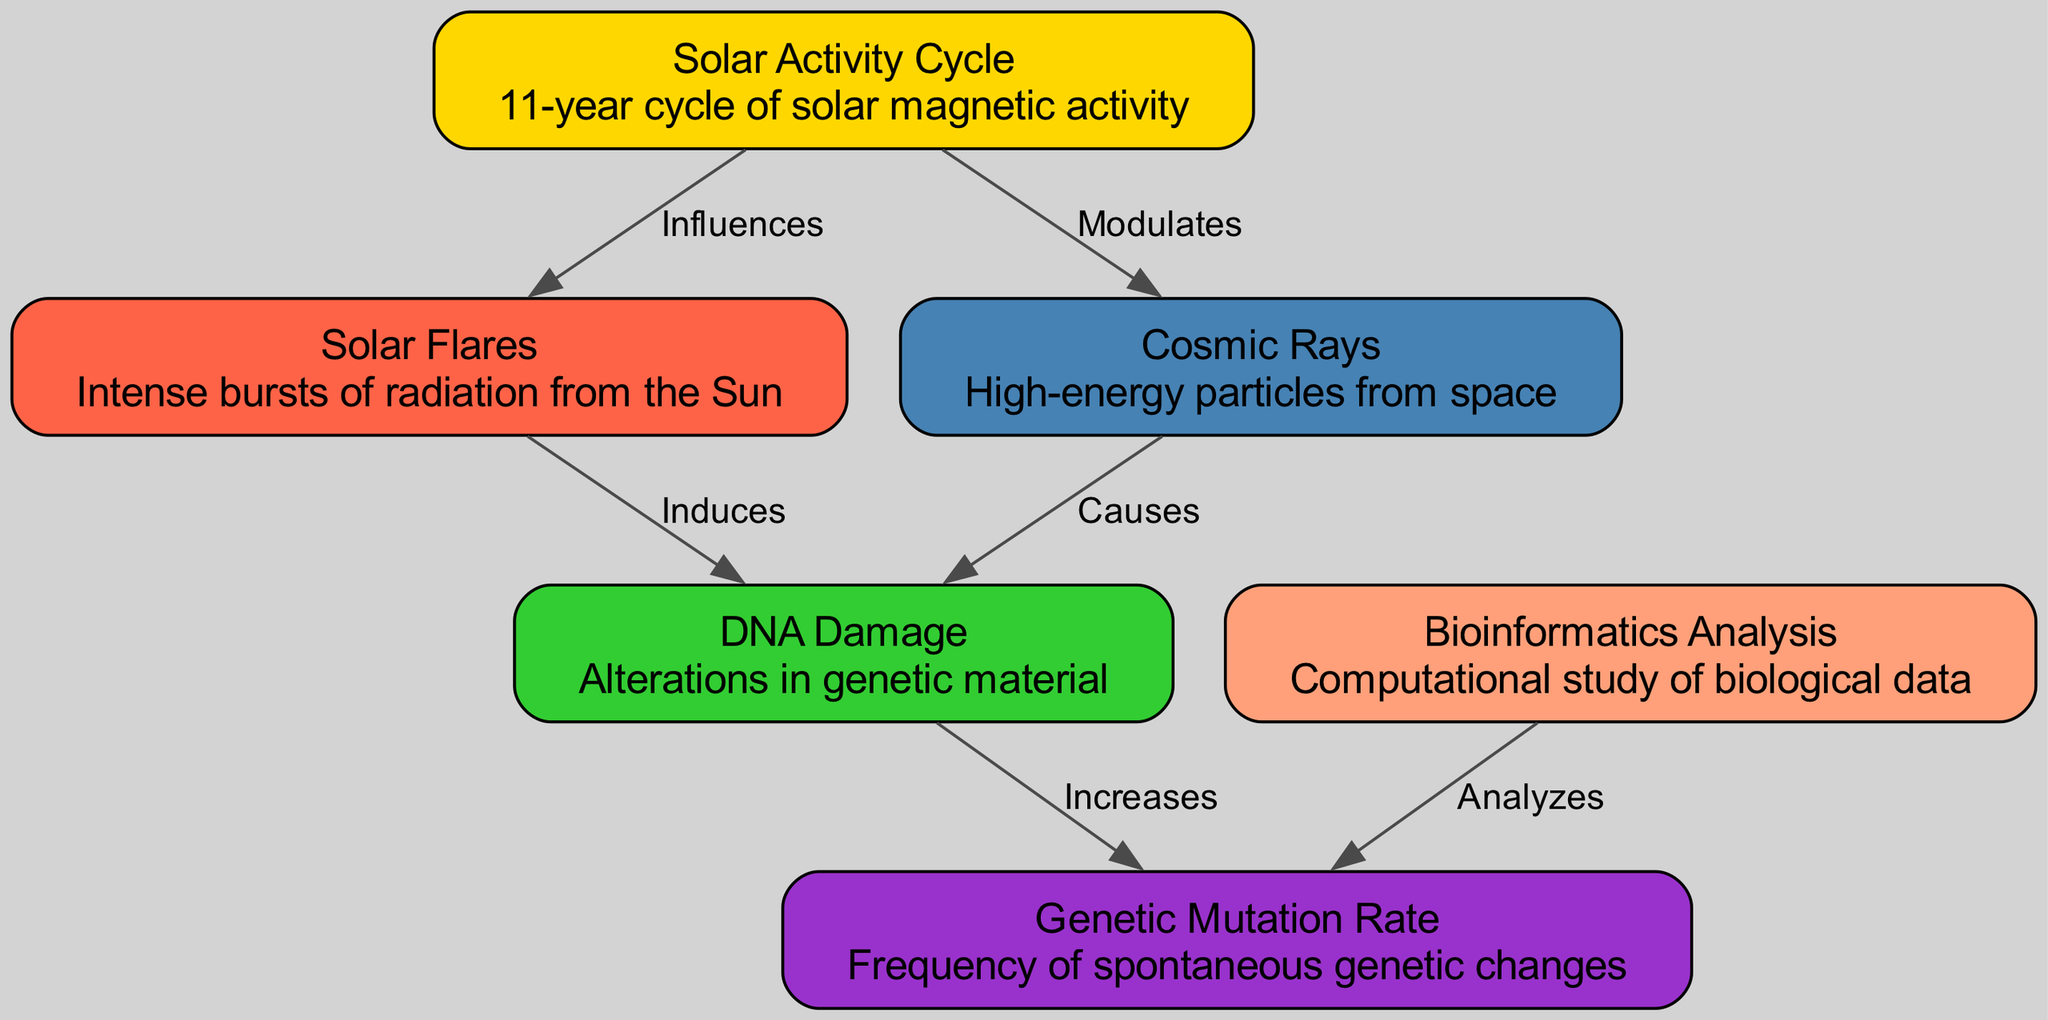What are the two main outputs from the solar activity cycle? The diagram indicates that the solar activity cycle influences solar flares and modulates cosmic rays, showing the direct relationships between the solar cycle and these aspects.
Answer: Solar flares and cosmic rays How many nodes are present in the diagram? By counting the distinct entities listed in the nodes section of the diagram, we find there are six nodes: solar activity cycle, solar flares, cosmic rays, DNA damage, mutation rate, and bioinformatics.
Answer: Six What does DNA damage increase? The edges suggest that DNA damage has a direct relationship with mutation rate, as indicated by the labeled edge that states DNA damage increases mutation rate.
Answer: Mutation rate What induces DNA damage? The diagram shows that solar flares induce DNA damage, which is explicitly mentioned in the labeling of the edge that connects these two nodes.
Answer: Solar flares Which two factors are analyzed through bioinformatics? Looking at the relationships depicted, bioinformatics is used to analyze the mutation rate, as indicated by the connection from bioinformatics to the mutation rate.
Answer: Mutation rate What is the relationship between cosmic rays and DNA damage? The edge labeled "Causes" between cosmic rays and DNA damage indicates that cosmic rays cause DNA damage according to the diagram.
Answer: Causes What does solar activity cycle influence? Referring to the relationships provided, the solar activity cycle influences both solar flares and cosmic rays, highlighted by the lines connecting these nodes.
Answer: Solar flares and cosmic rays How many edges are in the diagram? By counting the connections (edges) drawn between the nodes in the diagram, one can see there are six relationships depicted.
Answer: Six What type of analysis is bioinformatics involved in? The diagram explicitly states that bioinformatics analysis relates to the mutation rate, indicating the specific focus of this computational study.
Answer: Mutation rate 